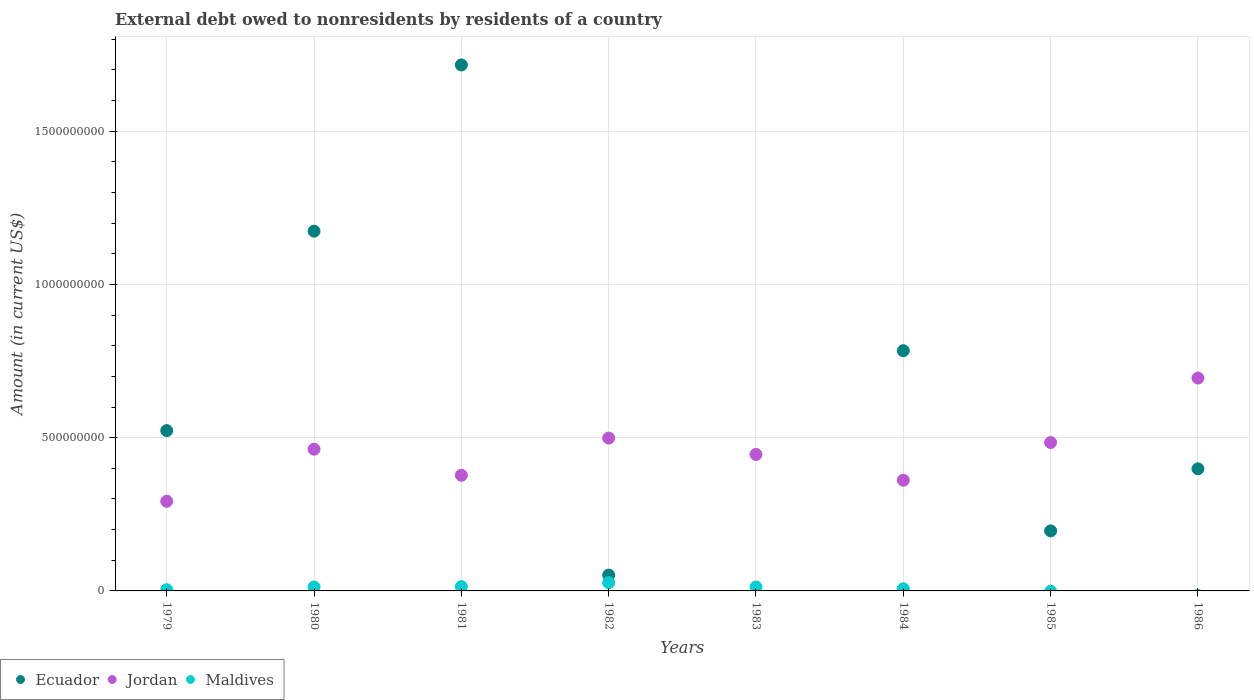Is the number of dotlines equal to the number of legend labels?
Provide a succinct answer. No. What is the external debt owed by residents in Jordan in 1986?
Keep it short and to the point. 6.94e+08. Across all years, what is the maximum external debt owed by residents in Maldives?
Your response must be concise. 2.70e+07. Across all years, what is the minimum external debt owed by residents in Maldives?
Make the answer very short. 0. What is the total external debt owed by residents in Maldives in the graph?
Your answer should be compact. 7.74e+07. What is the difference between the external debt owed by residents in Ecuador in 1980 and that in 1984?
Ensure brevity in your answer.  3.90e+08. What is the difference between the external debt owed by residents in Ecuador in 1983 and the external debt owed by residents in Jordan in 1986?
Your answer should be compact. -6.94e+08. What is the average external debt owed by residents in Maldives per year?
Provide a succinct answer. 9.68e+06. In the year 1984, what is the difference between the external debt owed by residents in Ecuador and external debt owed by residents in Jordan?
Your answer should be compact. 4.23e+08. What is the ratio of the external debt owed by residents in Jordan in 1979 to that in 1980?
Provide a short and direct response. 0.63. Is the external debt owed by residents in Jordan in 1979 less than that in 1981?
Your answer should be compact. Yes. What is the difference between the highest and the second highest external debt owed by residents in Ecuador?
Make the answer very short. 5.42e+08. What is the difference between the highest and the lowest external debt owed by residents in Ecuador?
Keep it short and to the point. 1.72e+09. In how many years, is the external debt owed by residents in Ecuador greater than the average external debt owed by residents in Ecuador taken over all years?
Ensure brevity in your answer.  3. Is the sum of the external debt owed by residents in Jordan in 1980 and 1984 greater than the maximum external debt owed by residents in Maldives across all years?
Offer a very short reply. Yes. Does the external debt owed by residents in Ecuador monotonically increase over the years?
Give a very brief answer. No. What is the difference between two consecutive major ticks on the Y-axis?
Provide a short and direct response. 5.00e+08. Are the values on the major ticks of Y-axis written in scientific E-notation?
Give a very brief answer. No. How many legend labels are there?
Give a very brief answer. 3. How are the legend labels stacked?
Keep it short and to the point. Horizontal. What is the title of the graph?
Your answer should be compact. External debt owed to nonresidents by residents of a country. What is the label or title of the X-axis?
Offer a terse response. Years. What is the Amount (in current US$) in Ecuador in 1979?
Keep it short and to the point. 5.23e+08. What is the Amount (in current US$) in Jordan in 1979?
Keep it short and to the point. 2.93e+08. What is the Amount (in current US$) of Maldives in 1979?
Provide a succinct answer. 3.91e+06. What is the Amount (in current US$) of Ecuador in 1980?
Offer a terse response. 1.17e+09. What is the Amount (in current US$) in Jordan in 1980?
Ensure brevity in your answer.  4.62e+08. What is the Amount (in current US$) in Maldives in 1980?
Offer a terse response. 1.29e+07. What is the Amount (in current US$) of Ecuador in 1981?
Your response must be concise. 1.72e+09. What is the Amount (in current US$) of Jordan in 1981?
Your answer should be very brief. 3.77e+08. What is the Amount (in current US$) in Maldives in 1981?
Provide a short and direct response. 1.39e+07. What is the Amount (in current US$) of Ecuador in 1982?
Make the answer very short. 5.17e+07. What is the Amount (in current US$) of Jordan in 1982?
Your answer should be very brief. 4.99e+08. What is the Amount (in current US$) in Maldives in 1982?
Give a very brief answer. 2.70e+07. What is the Amount (in current US$) in Ecuador in 1983?
Provide a short and direct response. 0. What is the Amount (in current US$) in Jordan in 1983?
Make the answer very short. 4.45e+08. What is the Amount (in current US$) of Maldives in 1983?
Keep it short and to the point. 1.28e+07. What is the Amount (in current US$) in Ecuador in 1984?
Offer a terse response. 7.84e+08. What is the Amount (in current US$) in Jordan in 1984?
Give a very brief answer. 3.61e+08. What is the Amount (in current US$) of Maldives in 1984?
Offer a terse response. 6.90e+06. What is the Amount (in current US$) in Ecuador in 1985?
Your answer should be compact. 1.96e+08. What is the Amount (in current US$) in Jordan in 1985?
Give a very brief answer. 4.84e+08. What is the Amount (in current US$) in Maldives in 1985?
Your response must be concise. 0. What is the Amount (in current US$) of Ecuador in 1986?
Make the answer very short. 3.98e+08. What is the Amount (in current US$) in Jordan in 1986?
Give a very brief answer. 6.94e+08. Across all years, what is the maximum Amount (in current US$) of Ecuador?
Give a very brief answer. 1.72e+09. Across all years, what is the maximum Amount (in current US$) in Jordan?
Your answer should be very brief. 6.94e+08. Across all years, what is the maximum Amount (in current US$) of Maldives?
Ensure brevity in your answer.  2.70e+07. Across all years, what is the minimum Amount (in current US$) of Jordan?
Offer a terse response. 2.93e+08. What is the total Amount (in current US$) in Ecuador in the graph?
Give a very brief answer. 4.84e+09. What is the total Amount (in current US$) of Jordan in the graph?
Your answer should be very brief. 3.62e+09. What is the total Amount (in current US$) in Maldives in the graph?
Offer a very short reply. 7.74e+07. What is the difference between the Amount (in current US$) in Ecuador in 1979 and that in 1980?
Your response must be concise. -6.51e+08. What is the difference between the Amount (in current US$) of Jordan in 1979 and that in 1980?
Make the answer very short. -1.70e+08. What is the difference between the Amount (in current US$) of Maldives in 1979 and that in 1980?
Provide a short and direct response. -8.99e+06. What is the difference between the Amount (in current US$) in Ecuador in 1979 and that in 1981?
Provide a succinct answer. -1.19e+09. What is the difference between the Amount (in current US$) in Jordan in 1979 and that in 1981?
Provide a succinct answer. -8.48e+07. What is the difference between the Amount (in current US$) of Maldives in 1979 and that in 1981?
Keep it short and to the point. -1.00e+07. What is the difference between the Amount (in current US$) in Ecuador in 1979 and that in 1982?
Your answer should be compact. 4.71e+08. What is the difference between the Amount (in current US$) of Jordan in 1979 and that in 1982?
Ensure brevity in your answer.  -2.06e+08. What is the difference between the Amount (in current US$) in Maldives in 1979 and that in 1982?
Ensure brevity in your answer.  -2.30e+07. What is the difference between the Amount (in current US$) in Jordan in 1979 and that in 1983?
Your answer should be very brief. -1.53e+08. What is the difference between the Amount (in current US$) of Maldives in 1979 and that in 1983?
Keep it short and to the point. -8.94e+06. What is the difference between the Amount (in current US$) of Ecuador in 1979 and that in 1984?
Your answer should be compact. -2.61e+08. What is the difference between the Amount (in current US$) in Jordan in 1979 and that in 1984?
Your answer should be compact. -6.85e+07. What is the difference between the Amount (in current US$) in Maldives in 1979 and that in 1984?
Ensure brevity in your answer.  -3.00e+06. What is the difference between the Amount (in current US$) in Ecuador in 1979 and that in 1985?
Offer a terse response. 3.27e+08. What is the difference between the Amount (in current US$) of Jordan in 1979 and that in 1985?
Make the answer very short. -1.92e+08. What is the difference between the Amount (in current US$) of Ecuador in 1979 and that in 1986?
Keep it short and to the point. 1.25e+08. What is the difference between the Amount (in current US$) of Jordan in 1979 and that in 1986?
Offer a terse response. -4.02e+08. What is the difference between the Amount (in current US$) in Ecuador in 1980 and that in 1981?
Give a very brief answer. -5.42e+08. What is the difference between the Amount (in current US$) in Jordan in 1980 and that in 1981?
Your answer should be very brief. 8.50e+07. What is the difference between the Amount (in current US$) in Maldives in 1980 and that in 1981?
Ensure brevity in your answer.  -1.02e+06. What is the difference between the Amount (in current US$) in Ecuador in 1980 and that in 1982?
Your answer should be compact. 1.12e+09. What is the difference between the Amount (in current US$) in Jordan in 1980 and that in 1982?
Offer a very short reply. -3.64e+07. What is the difference between the Amount (in current US$) in Maldives in 1980 and that in 1982?
Your response must be concise. -1.41e+07. What is the difference between the Amount (in current US$) in Jordan in 1980 and that in 1983?
Ensure brevity in your answer.  1.70e+07. What is the difference between the Amount (in current US$) of Maldives in 1980 and that in 1983?
Offer a very short reply. 5.40e+04. What is the difference between the Amount (in current US$) in Ecuador in 1980 and that in 1984?
Keep it short and to the point. 3.90e+08. What is the difference between the Amount (in current US$) of Jordan in 1980 and that in 1984?
Your answer should be very brief. 1.01e+08. What is the difference between the Amount (in current US$) in Maldives in 1980 and that in 1984?
Offer a very short reply. 6.00e+06. What is the difference between the Amount (in current US$) of Ecuador in 1980 and that in 1985?
Make the answer very short. 9.78e+08. What is the difference between the Amount (in current US$) in Jordan in 1980 and that in 1985?
Your answer should be very brief. -2.18e+07. What is the difference between the Amount (in current US$) of Ecuador in 1980 and that in 1986?
Give a very brief answer. 7.75e+08. What is the difference between the Amount (in current US$) of Jordan in 1980 and that in 1986?
Your response must be concise. -2.32e+08. What is the difference between the Amount (in current US$) in Ecuador in 1981 and that in 1982?
Your answer should be very brief. 1.66e+09. What is the difference between the Amount (in current US$) in Jordan in 1981 and that in 1982?
Your answer should be compact. -1.21e+08. What is the difference between the Amount (in current US$) of Maldives in 1981 and that in 1982?
Provide a short and direct response. -1.30e+07. What is the difference between the Amount (in current US$) of Jordan in 1981 and that in 1983?
Your answer should be very brief. -6.80e+07. What is the difference between the Amount (in current US$) of Maldives in 1981 and that in 1983?
Provide a succinct answer. 1.07e+06. What is the difference between the Amount (in current US$) of Ecuador in 1981 and that in 1984?
Provide a succinct answer. 9.32e+08. What is the difference between the Amount (in current US$) of Jordan in 1981 and that in 1984?
Provide a succinct answer. 1.63e+07. What is the difference between the Amount (in current US$) of Maldives in 1981 and that in 1984?
Give a very brief answer. 7.01e+06. What is the difference between the Amount (in current US$) of Ecuador in 1981 and that in 1985?
Your answer should be very brief. 1.52e+09. What is the difference between the Amount (in current US$) in Jordan in 1981 and that in 1985?
Offer a terse response. -1.07e+08. What is the difference between the Amount (in current US$) in Ecuador in 1981 and that in 1986?
Give a very brief answer. 1.32e+09. What is the difference between the Amount (in current US$) of Jordan in 1981 and that in 1986?
Provide a short and direct response. -3.17e+08. What is the difference between the Amount (in current US$) of Jordan in 1982 and that in 1983?
Your answer should be very brief. 5.35e+07. What is the difference between the Amount (in current US$) of Maldives in 1982 and that in 1983?
Ensure brevity in your answer.  1.41e+07. What is the difference between the Amount (in current US$) in Ecuador in 1982 and that in 1984?
Your answer should be compact. -7.32e+08. What is the difference between the Amount (in current US$) of Jordan in 1982 and that in 1984?
Provide a short and direct response. 1.38e+08. What is the difference between the Amount (in current US$) in Maldives in 1982 and that in 1984?
Your response must be concise. 2.01e+07. What is the difference between the Amount (in current US$) in Ecuador in 1982 and that in 1985?
Provide a short and direct response. -1.44e+08. What is the difference between the Amount (in current US$) of Jordan in 1982 and that in 1985?
Provide a succinct answer. 1.47e+07. What is the difference between the Amount (in current US$) in Ecuador in 1982 and that in 1986?
Keep it short and to the point. -3.47e+08. What is the difference between the Amount (in current US$) of Jordan in 1982 and that in 1986?
Make the answer very short. -1.96e+08. What is the difference between the Amount (in current US$) in Jordan in 1983 and that in 1984?
Your answer should be compact. 8.43e+07. What is the difference between the Amount (in current US$) in Maldives in 1983 and that in 1984?
Ensure brevity in your answer.  5.94e+06. What is the difference between the Amount (in current US$) in Jordan in 1983 and that in 1985?
Give a very brief answer. -3.88e+07. What is the difference between the Amount (in current US$) of Jordan in 1983 and that in 1986?
Your response must be concise. -2.49e+08. What is the difference between the Amount (in current US$) of Ecuador in 1984 and that in 1985?
Give a very brief answer. 5.88e+08. What is the difference between the Amount (in current US$) in Jordan in 1984 and that in 1985?
Your answer should be compact. -1.23e+08. What is the difference between the Amount (in current US$) of Ecuador in 1984 and that in 1986?
Make the answer very short. 3.85e+08. What is the difference between the Amount (in current US$) of Jordan in 1984 and that in 1986?
Ensure brevity in your answer.  -3.33e+08. What is the difference between the Amount (in current US$) of Ecuador in 1985 and that in 1986?
Provide a succinct answer. -2.03e+08. What is the difference between the Amount (in current US$) in Jordan in 1985 and that in 1986?
Give a very brief answer. -2.10e+08. What is the difference between the Amount (in current US$) of Ecuador in 1979 and the Amount (in current US$) of Jordan in 1980?
Keep it short and to the point. 6.07e+07. What is the difference between the Amount (in current US$) in Ecuador in 1979 and the Amount (in current US$) in Maldives in 1980?
Give a very brief answer. 5.10e+08. What is the difference between the Amount (in current US$) in Jordan in 1979 and the Amount (in current US$) in Maldives in 1980?
Your answer should be compact. 2.80e+08. What is the difference between the Amount (in current US$) of Ecuador in 1979 and the Amount (in current US$) of Jordan in 1981?
Your answer should be very brief. 1.46e+08. What is the difference between the Amount (in current US$) of Ecuador in 1979 and the Amount (in current US$) of Maldives in 1981?
Give a very brief answer. 5.09e+08. What is the difference between the Amount (in current US$) of Jordan in 1979 and the Amount (in current US$) of Maldives in 1981?
Ensure brevity in your answer.  2.79e+08. What is the difference between the Amount (in current US$) in Ecuador in 1979 and the Amount (in current US$) in Jordan in 1982?
Offer a very short reply. 2.42e+07. What is the difference between the Amount (in current US$) of Ecuador in 1979 and the Amount (in current US$) of Maldives in 1982?
Your response must be concise. 4.96e+08. What is the difference between the Amount (in current US$) of Jordan in 1979 and the Amount (in current US$) of Maldives in 1982?
Make the answer very short. 2.66e+08. What is the difference between the Amount (in current US$) of Ecuador in 1979 and the Amount (in current US$) of Jordan in 1983?
Give a very brief answer. 7.77e+07. What is the difference between the Amount (in current US$) of Ecuador in 1979 and the Amount (in current US$) of Maldives in 1983?
Offer a very short reply. 5.10e+08. What is the difference between the Amount (in current US$) in Jordan in 1979 and the Amount (in current US$) in Maldives in 1983?
Your answer should be compact. 2.80e+08. What is the difference between the Amount (in current US$) in Ecuador in 1979 and the Amount (in current US$) in Jordan in 1984?
Give a very brief answer. 1.62e+08. What is the difference between the Amount (in current US$) in Ecuador in 1979 and the Amount (in current US$) in Maldives in 1984?
Your answer should be very brief. 5.16e+08. What is the difference between the Amount (in current US$) in Jordan in 1979 and the Amount (in current US$) in Maldives in 1984?
Your answer should be compact. 2.86e+08. What is the difference between the Amount (in current US$) in Ecuador in 1979 and the Amount (in current US$) in Jordan in 1985?
Ensure brevity in your answer.  3.89e+07. What is the difference between the Amount (in current US$) in Ecuador in 1979 and the Amount (in current US$) in Jordan in 1986?
Your response must be concise. -1.71e+08. What is the difference between the Amount (in current US$) of Ecuador in 1980 and the Amount (in current US$) of Jordan in 1981?
Provide a succinct answer. 7.96e+08. What is the difference between the Amount (in current US$) of Ecuador in 1980 and the Amount (in current US$) of Maldives in 1981?
Offer a terse response. 1.16e+09. What is the difference between the Amount (in current US$) in Jordan in 1980 and the Amount (in current US$) in Maldives in 1981?
Offer a terse response. 4.48e+08. What is the difference between the Amount (in current US$) in Ecuador in 1980 and the Amount (in current US$) in Jordan in 1982?
Provide a succinct answer. 6.75e+08. What is the difference between the Amount (in current US$) in Ecuador in 1980 and the Amount (in current US$) in Maldives in 1982?
Make the answer very short. 1.15e+09. What is the difference between the Amount (in current US$) in Jordan in 1980 and the Amount (in current US$) in Maldives in 1982?
Make the answer very short. 4.35e+08. What is the difference between the Amount (in current US$) of Ecuador in 1980 and the Amount (in current US$) of Jordan in 1983?
Offer a terse response. 7.28e+08. What is the difference between the Amount (in current US$) of Ecuador in 1980 and the Amount (in current US$) of Maldives in 1983?
Your answer should be compact. 1.16e+09. What is the difference between the Amount (in current US$) of Jordan in 1980 and the Amount (in current US$) of Maldives in 1983?
Your answer should be compact. 4.49e+08. What is the difference between the Amount (in current US$) in Ecuador in 1980 and the Amount (in current US$) in Jordan in 1984?
Provide a succinct answer. 8.13e+08. What is the difference between the Amount (in current US$) of Ecuador in 1980 and the Amount (in current US$) of Maldives in 1984?
Provide a short and direct response. 1.17e+09. What is the difference between the Amount (in current US$) in Jordan in 1980 and the Amount (in current US$) in Maldives in 1984?
Provide a succinct answer. 4.55e+08. What is the difference between the Amount (in current US$) in Ecuador in 1980 and the Amount (in current US$) in Jordan in 1985?
Offer a terse response. 6.90e+08. What is the difference between the Amount (in current US$) of Ecuador in 1980 and the Amount (in current US$) of Jordan in 1986?
Provide a succinct answer. 4.79e+08. What is the difference between the Amount (in current US$) in Ecuador in 1981 and the Amount (in current US$) in Jordan in 1982?
Offer a very short reply. 1.22e+09. What is the difference between the Amount (in current US$) of Ecuador in 1981 and the Amount (in current US$) of Maldives in 1982?
Provide a short and direct response. 1.69e+09. What is the difference between the Amount (in current US$) of Jordan in 1981 and the Amount (in current US$) of Maldives in 1982?
Offer a very short reply. 3.50e+08. What is the difference between the Amount (in current US$) in Ecuador in 1981 and the Amount (in current US$) in Jordan in 1983?
Keep it short and to the point. 1.27e+09. What is the difference between the Amount (in current US$) in Ecuador in 1981 and the Amount (in current US$) in Maldives in 1983?
Make the answer very short. 1.70e+09. What is the difference between the Amount (in current US$) of Jordan in 1981 and the Amount (in current US$) of Maldives in 1983?
Your response must be concise. 3.64e+08. What is the difference between the Amount (in current US$) of Ecuador in 1981 and the Amount (in current US$) of Jordan in 1984?
Offer a very short reply. 1.36e+09. What is the difference between the Amount (in current US$) of Ecuador in 1981 and the Amount (in current US$) of Maldives in 1984?
Provide a short and direct response. 1.71e+09. What is the difference between the Amount (in current US$) in Jordan in 1981 and the Amount (in current US$) in Maldives in 1984?
Give a very brief answer. 3.70e+08. What is the difference between the Amount (in current US$) in Ecuador in 1981 and the Amount (in current US$) in Jordan in 1985?
Offer a very short reply. 1.23e+09. What is the difference between the Amount (in current US$) of Ecuador in 1981 and the Amount (in current US$) of Jordan in 1986?
Give a very brief answer. 1.02e+09. What is the difference between the Amount (in current US$) in Ecuador in 1982 and the Amount (in current US$) in Jordan in 1983?
Your response must be concise. -3.94e+08. What is the difference between the Amount (in current US$) in Ecuador in 1982 and the Amount (in current US$) in Maldives in 1983?
Offer a terse response. 3.88e+07. What is the difference between the Amount (in current US$) of Jordan in 1982 and the Amount (in current US$) of Maldives in 1983?
Give a very brief answer. 4.86e+08. What is the difference between the Amount (in current US$) in Ecuador in 1982 and the Amount (in current US$) in Jordan in 1984?
Provide a succinct answer. -3.09e+08. What is the difference between the Amount (in current US$) of Ecuador in 1982 and the Amount (in current US$) of Maldives in 1984?
Make the answer very short. 4.48e+07. What is the difference between the Amount (in current US$) of Jordan in 1982 and the Amount (in current US$) of Maldives in 1984?
Your answer should be very brief. 4.92e+08. What is the difference between the Amount (in current US$) in Ecuador in 1982 and the Amount (in current US$) in Jordan in 1985?
Keep it short and to the point. -4.32e+08. What is the difference between the Amount (in current US$) in Ecuador in 1982 and the Amount (in current US$) in Jordan in 1986?
Make the answer very short. -6.43e+08. What is the difference between the Amount (in current US$) in Jordan in 1983 and the Amount (in current US$) in Maldives in 1984?
Offer a very short reply. 4.38e+08. What is the difference between the Amount (in current US$) of Ecuador in 1984 and the Amount (in current US$) of Jordan in 1985?
Give a very brief answer. 3.00e+08. What is the difference between the Amount (in current US$) of Ecuador in 1984 and the Amount (in current US$) of Jordan in 1986?
Your response must be concise. 8.92e+07. What is the difference between the Amount (in current US$) of Ecuador in 1985 and the Amount (in current US$) of Jordan in 1986?
Your answer should be very brief. -4.99e+08. What is the average Amount (in current US$) in Ecuador per year?
Provide a short and direct response. 6.05e+08. What is the average Amount (in current US$) in Jordan per year?
Provide a succinct answer. 4.52e+08. What is the average Amount (in current US$) of Maldives per year?
Give a very brief answer. 9.68e+06. In the year 1979, what is the difference between the Amount (in current US$) of Ecuador and Amount (in current US$) of Jordan?
Ensure brevity in your answer.  2.30e+08. In the year 1979, what is the difference between the Amount (in current US$) in Ecuador and Amount (in current US$) in Maldives?
Your answer should be compact. 5.19e+08. In the year 1979, what is the difference between the Amount (in current US$) of Jordan and Amount (in current US$) of Maldives?
Offer a terse response. 2.89e+08. In the year 1980, what is the difference between the Amount (in current US$) of Ecuador and Amount (in current US$) of Jordan?
Your answer should be compact. 7.11e+08. In the year 1980, what is the difference between the Amount (in current US$) in Ecuador and Amount (in current US$) in Maldives?
Offer a terse response. 1.16e+09. In the year 1980, what is the difference between the Amount (in current US$) in Jordan and Amount (in current US$) in Maldives?
Offer a very short reply. 4.49e+08. In the year 1981, what is the difference between the Amount (in current US$) of Ecuador and Amount (in current US$) of Jordan?
Provide a succinct answer. 1.34e+09. In the year 1981, what is the difference between the Amount (in current US$) in Ecuador and Amount (in current US$) in Maldives?
Offer a terse response. 1.70e+09. In the year 1981, what is the difference between the Amount (in current US$) of Jordan and Amount (in current US$) of Maldives?
Offer a very short reply. 3.63e+08. In the year 1982, what is the difference between the Amount (in current US$) of Ecuador and Amount (in current US$) of Jordan?
Make the answer very short. -4.47e+08. In the year 1982, what is the difference between the Amount (in current US$) of Ecuador and Amount (in current US$) of Maldives?
Give a very brief answer. 2.47e+07. In the year 1982, what is the difference between the Amount (in current US$) of Jordan and Amount (in current US$) of Maldives?
Your answer should be compact. 4.72e+08. In the year 1983, what is the difference between the Amount (in current US$) of Jordan and Amount (in current US$) of Maldives?
Offer a very short reply. 4.32e+08. In the year 1984, what is the difference between the Amount (in current US$) of Ecuador and Amount (in current US$) of Jordan?
Make the answer very short. 4.23e+08. In the year 1984, what is the difference between the Amount (in current US$) of Ecuador and Amount (in current US$) of Maldives?
Provide a succinct answer. 7.77e+08. In the year 1984, what is the difference between the Amount (in current US$) of Jordan and Amount (in current US$) of Maldives?
Your response must be concise. 3.54e+08. In the year 1985, what is the difference between the Amount (in current US$) of Ecuador and Amount (in current US$) of Jordan?
Your answer should be compact. -2.88e+08. In the year 1986, what is the difference between the Amount (in current US$) of Ecuador and Amount (in current US$) of Jordan?
Offer a very short reply. -2.96e+08. What is the ratio of the Amount (in current US$) in Ecuador in 1979 to that in 1980?
Your response must be concise. 0.45. What is the ratio of the Amount (in current US$) in Jordan in 1979 to that in 1980?
Your response must be concise. 0.63. What is the ratio of the Amount (in current US$) of Maldives in 1979 to that in 1980?
Ensure brevity in your answer.  0.3. What is the ratio of the Amount (in current US$) of Ecuador in 1979 to that in 1981?
Your response must be concise. 0.3. What is the ratio of the Amount (in current US$) in Jordan in 1979 to that in 1981?
Give a very brief answer. 0.78. What is the ratio of the Amount (in current US$) of Maldives in 1979 to that in 1981?
Offer a very short reply. 0.28. What is the ratio of the Amount (in current US$) of Ecuador in 1979 to that in 1982?
Keep it short and to the point. 10.12. What is the ratio of the Amount (in current US$) in Jordan in 1979 to that in 1982?
Your response must be concise. 0.59. What is the ratio of the Amount (in current US$) of Maldives in 1979 to that in 1982?
Your answer should be compact. 0.14. What is the ratio of the Amount (in current US$) of Jordan in 1979 to that in 1983?
Your answer should be very brief. 0.66. What is the ratio of the Amount (in current US$) in Maldives in 1979 to that in 1983?
Offer a very short reply. 0.3. What is the ratio of the Amount (in current US$) in Ecuador in 1979 to that in 1984?
Give a very brief answer. 0.67. What is the ratio of the Amount (in current US$) of Jordan in 1979 to that in 1984?
Give a very brief answer. 0.81. What is the ratio of the Amount (in current US$) in Maldives in 1979 to that in 1984?
Your response must be concise. 0.57. What is the ratio of the Amount (in current US$) of Ecuador in 1979 to that in 1985?
Give a very brief answer. 2.67. What is the ratio of the Amount (in current US$) in Jordan in 1979 to that in 1985?
Offer a terse response. 0.6. What is the ratio of the Amount (in current US$) in Ecuador in 1979 to that in 1986?
Provide a succinct answer. 1.31. What is the ratio of the Amount (in current US$) in Jordan in 1979 to that in 1986?
Provide a short and direct response. 0.42. What is the ratio of the Amount (in current US$) of Ecuador in 1980 to that in 1981?
Keep it short and to the point. 0.68. What is the ratio of the Amount (in current US$) of Jordan in 1980 to that in 1981?
Your answer should be very brief. 1.23. What is the ratio of the Amount (in current US$) of Maldives in 1980 to that in 1981?
Your answer should be compact. 0.93. What is the ratio of the Amount (in current US$) of Ecuador in 1980 to that in 1982?
Provide a short and direct response. 22.72. What is the ratio of the Amount (in current US$) of Jordan in 1980 to that in 1982?
Ensure brevity in your answer.  0.93. What is the ratio of the Amount (in current US$) of Maldives in 1980 to that in 1982?
Ensure brevity in your answer.  0.48. What is the ratio of the Amount (in current US$) in Jordan in 1980 to that in 1983?
Your answer should be very brief. 1.04. What is the ratio of the Amount (in current US$) in Maldives in 1980 to that in 1983?
Your answer should be compact. 1. What is the ratio of the Amount (in current US$) in Ecuador in 1980 to that in 1984?
Keep it short and to the point. 1.5. What is the ratio of the Amount (in current US$) in Jordan in 1980 to that in 1984?
Give a very brief answer. 1.28. What is the ratio of the Amount (in current US$) in Maldives in 1980 to that in 1984?
Keep it short and to the point. 1.87. What is the ratio of the Amount (in current US$) in Ecuador in 1980 to that in 1985?
Offer a very short reply. 5.99. What is the ratio of the Amount (in current US$) in Jordan in 1980 to that in 1985?
Ensure brevity in your answer.  0.95. What is the ratio of the Amount (in current US$) in Ecuador in 1980 to that in 1986?
Give a very brief answer. 2.95. What is the ratio of the Amount (in current US$) of Jordan in 1980 to that in 1986?
Ensure brevity in your answer.  0.67. What is the ratio of the Amount (in current US$) of Ecuador in 1981 to that in 1982?
Offer a terse response. 33.22. What is the ratio of the Amount (in current US$) of Jordan in 1981 to that in 1982?
Offer a very short reply. 0.76. What is the ratio of the Amount (in current US$) of Maldives in 1981 to that in 1982?
Your answer should be compact. 0.52. What is the ratio of the Amount (in current US$) of Jordan in 1981 to that in 1983?
Your answer should be very brief. 0.85. What is the ratio of the Amount (in current US$) in Maldives in 1981 to that in 1983?
Your response must be concise. 1.08. What is the ratio of the Amount (in current US$) of Ecuador in 1981 to that in 1984?
Keep it short and to the point. 2.19. What is the ratio of the Amount (in current US$) in Jordan in 1981 to that in 1984?
Your answer should be compact. 1.05. What is the ratio of the Amount (in current US$) of Maldives in 1981 to that in 1984?
Your answer should be very brief. 2.02. What is the ratio of the Amount (in current US$) of Ecuador in 1981 to that in 1985?
Offer a very short reply. 8.76. What is the ratio of the Amount (in current US$) of Jordan in 1981 to that in 1985?
Make the answer very short. 0.78. What is the ratio of the Amount (in current US$) of Ecuador in 1981 to that in 1986?
Ensure brevity in your answer.  4.31. What is the ratio of the Amount (in current US$) of Jordan in 1981 to that in 1986?
Offer a very short reply. 0.54. What is the ratio of the Amount (in current US$) in Jordan in 1982 to that in 1983?
Ensure brevity in your answer.  1.12. What is the ratio of the Amount (in current US$) of Maldives in 1982 to that in 1983?
Make the answer very short. 2.1. What is the ratio of the Amount (in current US$) in Ecuador in 1982 to that in 1984?
Give a very brief answer. 0.07. What is the ratio of the Amount (in current US$) in Jordan in 1982 to that in 1984?
Provide a succinct answer. 1.38. What is the ratio of the Amount (in current US$) in Maldives in 1982 to that in 1984?
Your response must be concise. 3.9. What is the ratio of the Amount (in current US$) in Ecuador in 1982 to that in 1985?
Make the answer very short. 0.26. What is the ratio of the Amount (in current US$) in Jordan in 1982 to that in 1985?
Your answer should be very brief. 1.03. What is the ratio of the Amount (in current US$) of Ecuador in 1982 to that in 1986?
Provide a short and direct response. 0.13. What is the ratio of the Amount (in current US$) of Jordan in 1982 to that in 1986?
Your answer should be compact. 0.72. What is the ratio of the Amount (in current US$) of Jordan in 1983 to that in 1984?
Ensure brevity in your answer.  1.23. What is the ratio of the Amount (in current US$) of Maldives in 1983 to that in 1984?
Offer a very short reply. 1.86. What is the ratio of the Amount (in current US$) in Jordan in 1983 to that in 1985?
Your answer should be compact. 0.92. What is the ratio of the Amount (in current US$) of Jordan in 1983 to that in 1986?
Provide a short and direct response. 0.64. What is the ratio of the Amount (in current US$) of Ecuador in 1984 to that in 1985?
Ensure brevity in your answer.  4. What is the ratio of the Amount (in current US$) of Jordan in 1984 to that in 1985?
Provide a succinct answer. 0.75. What is the ratio of the Amount (in current US$) in Ecuador in 1984 to that in 1986?
Give a very brief answer. 1.97. What is the ratio of the Amount (in current US$) in Jordan in 1984 to that in 1986?
Give a very brief answer. 0.52. What is the ratio of the Amount (in current US$) in Ecuador in 1985 to that in 1986?
Provide a short and direct response. 0.49. What is the ratio of the Amount (in current US$) of Jordan in 1985 to that in 1986?
Provide a short and direct response. 0.7. What is the difference between the highest and the second highest Amount (in current US$) in Ecuador?
Provide a succinct answer. 5.42e+08. What is the difference between the highest and the second highest Amount (in current US$) in Jordan?
Your answer should be very brief. 1.96e+08. What is the difference between the highest and the second highest Amount (in current US$) of Maldives?
Offer a terse response. 1.30e+07. What is the difference between the highest and the lowest Amount (in current US$) of Ecuador?
Keep it short and to the point. 1.72e+09. What is the difference between the highest and the lowest Amount (in current US$) in Jordan?
Offer a very short reply. 4.02e+08. What is the difference between the highest and the lowest Amount (in current US$) in Maldives?
Make the answer very short. 2.70e+07. 